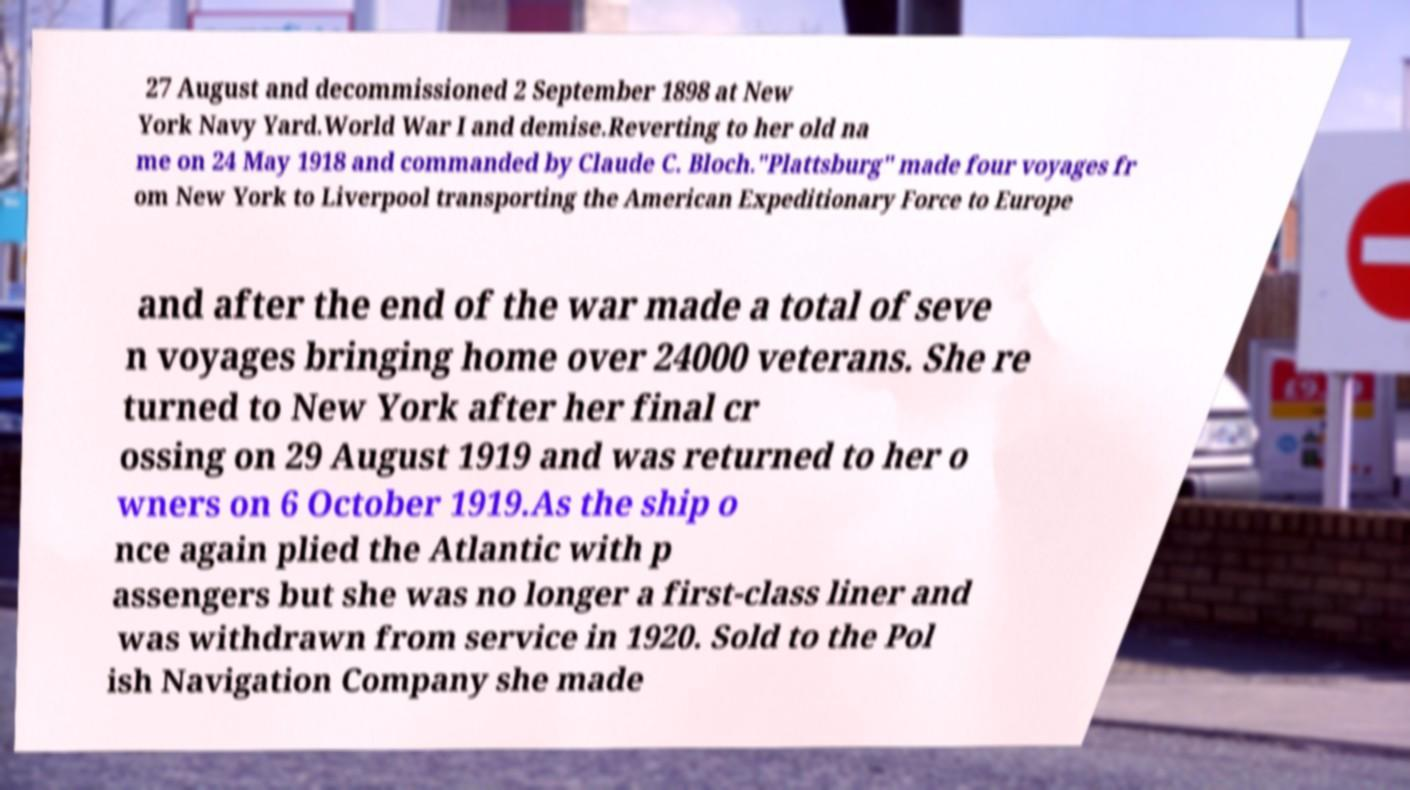Could you assist in decoding the text presented in this image and type it out clearly? 27 August and decommissioned 2 September 1898 at New York Navy Yard.World War I and demise.Reverting to her old na me on 24 May 1918 and commanded by Claude C. Bloch."Plattsburg" made four voyages fr om New York to Liverpool transporting the American Expeditionary Force to Europe and after the end of the war made a total of seve n voyages bringing home over 24000 veterans. She re turned to New York after her final cr ossing on 29 August 1919 and was returned to her o wners on 6 October 1919.As the ship o nce again plied the Atlantic with p assengers but she was no longer a first-class liner and was withdrawn from service in 1920. Sold to the Pol ish Navigation Company she made 